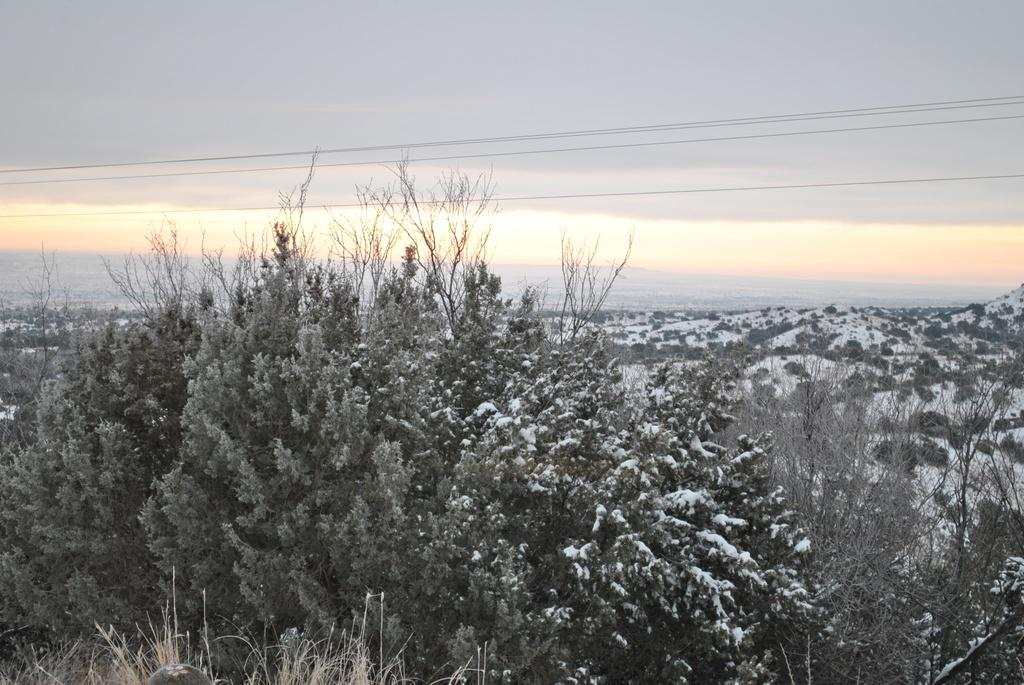What is in the foreground of the image? There are trees in the foreground of the image. What is the condition of the trees? The trees are covered with snow. What can be seen in the background of the image? The image appears to depict mountains in the background. What is visible in the sky in the image? The sky is visible in the background of the image. Can you hear the sound of a stick breaking in the image? There is no sound present in the image, and therefore no indication of a stick breaking. What type of hearing aid is visible on the trees in the image? There are no hearing aids present in the image; it features trees covered with snow and mountains in the background. 